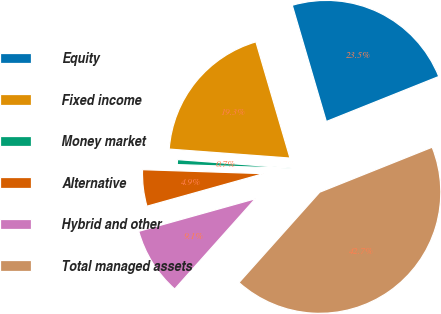<chart> <loc_0><loc_0><loc_500><loc_500><pie_chart><fcel>Equity<fcel>Fixed income<fcel>Money market<fcel>Alternative<fcel>Hybrid and other<fcel>Total managed assets<nl><fcel>23.48%<fcel>19.28%<fcel>0.66%<fcel>4.86%<fcel>9.06%<fcel>42.66%<nl></chart> 